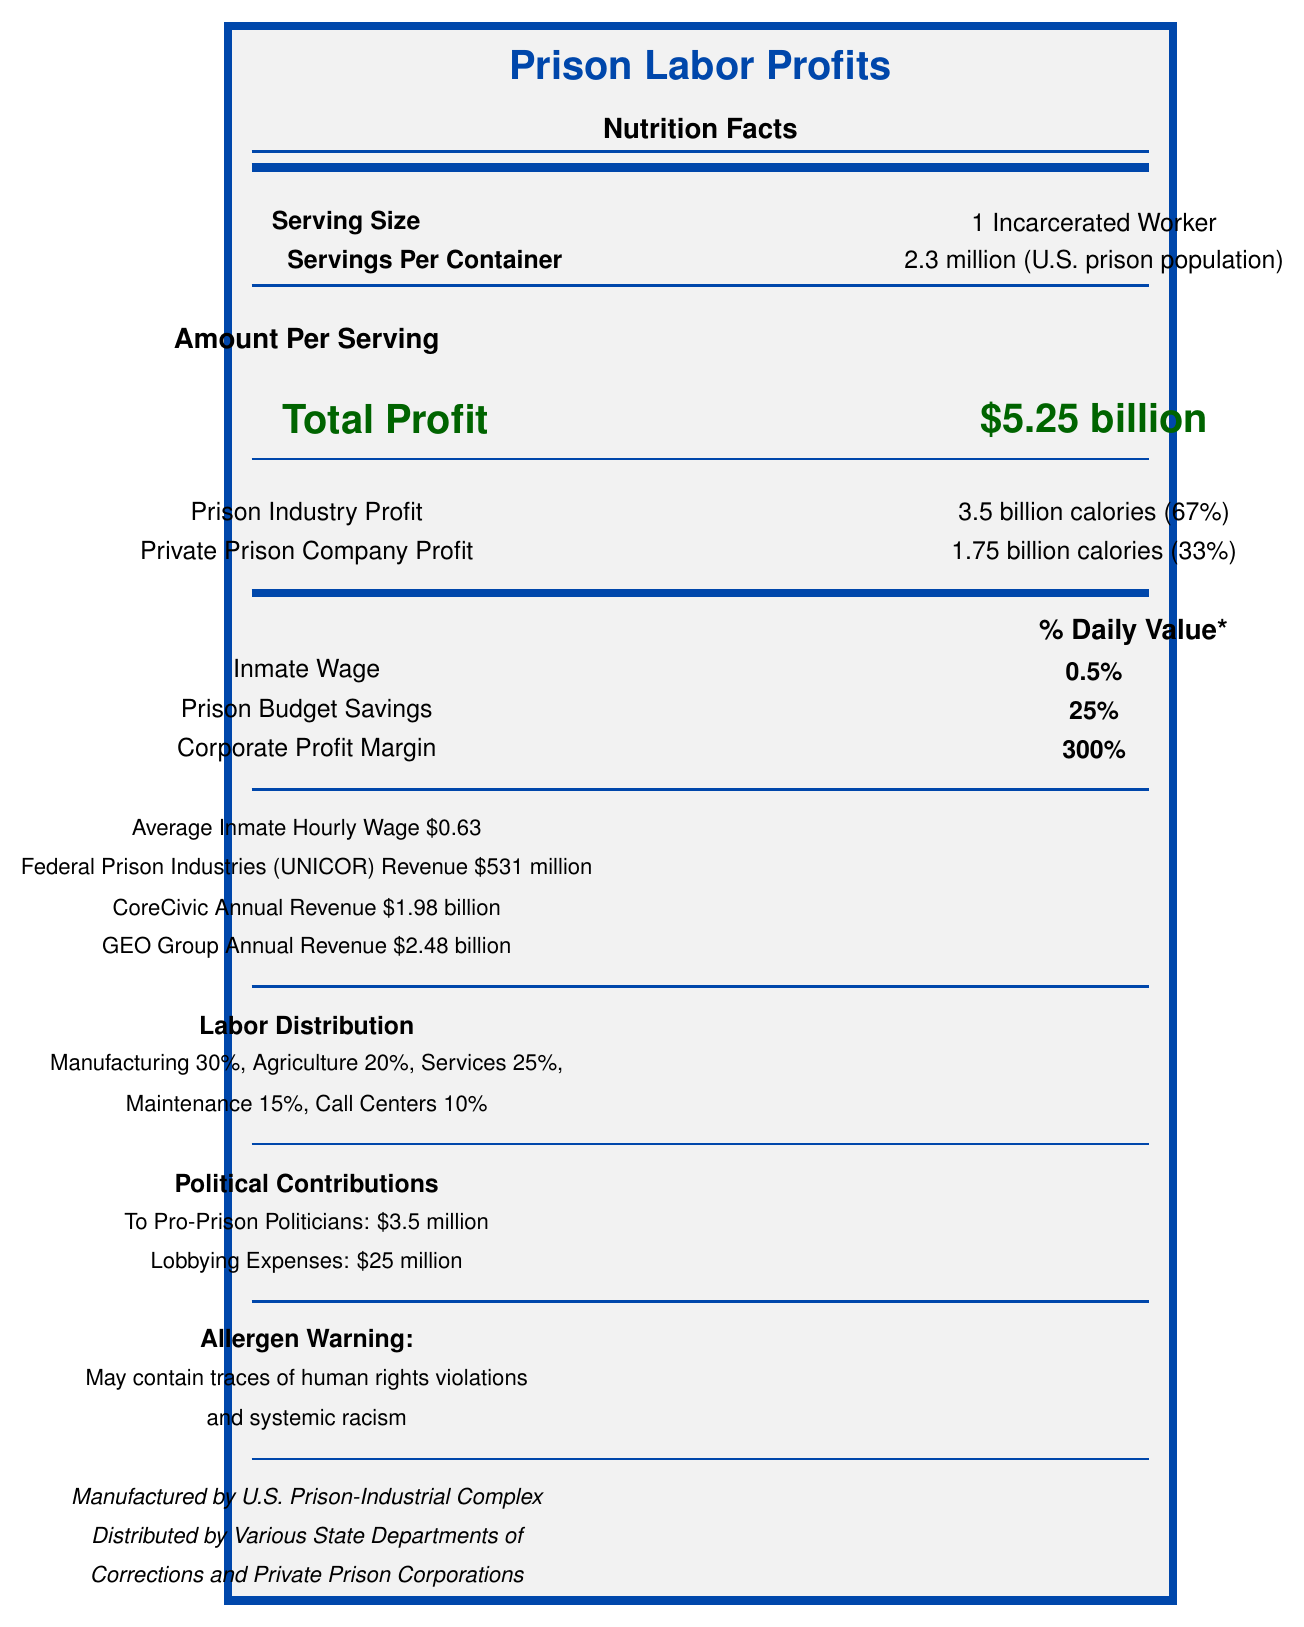what is the total profit from prison labor? The document lists "Total Profit" as $5.25 billion.
Answer: $5.25 billion what percentage of the profit do private prison companies take? The document specifies "Private Prison Company Profit" as 33%.
Answer: 33% what is the average hourly wage for an inmate worker? The document mentions that the "Average Inmate Hourly Wage" is $0.63.
Answer: $0.63 how much do federal prison industries (UNICOR) make annually? The "Federal Prison Industries (UNICOR) Revenue" is listed as $531 million.
Answer: $531 million which industry has the highest distribution of prison labor? The "Labor Distribution" section lists "Manufacturing" at 30%.
Answer: Manufacturing what is the corporate profit margin for prison labor? The document lists "Corporate Profit Margin" as 300%.
Answer: 300% how much are the lobbying expenses related to prison labor? The document lists "Lobbying Expenses" as $25 million.
Answer: $25 million what percentage of prison labor is involved in call centers? The "Labor Distribution" section states that call centers constitute 10% of prison labor.
Answer: 10% which company has the highest annual revenue from prison labor? 
A. UNICOR
B. CoreCivic
C. GEO Group The document lists "GEO Group Annual Revenue" as $2.48 billion, which is higher than the other listed companies.
Answer: C how much are prison budget savings attributed to utilizing prison labor? 
A. 5%
B. 10%
C. 25%
D. 50% The document specifies "Prison Budget Savings" as 25%.
Answer: C does the document indicate a reduction in recidivism due to prison labor programs? The "Recidivism Impact" section shows a "Reduction in Repeat Offenses" as -2%, indicating no reduction.
Answer: No summarize the key components of the prison labor profits document. The detailed summary includes the profits, wage distribution, labor sectors, political contributions, and the impact on recidivism rates.
Answer: The document details the profits generated from prison labor, noting significant total profits of $5.25 billion, with private prison companies obtaining 33% of the total. Inmate wages are low, averaging $0.63 per hour. The labor distribution spans various industries, with manufacturing at 30%. Political contributions and lobbying expenses amount to millions, and there are negative implications on recidivism rates. what are the ingredients listed in the document? The "Ingredients" section lists these as the components.
Answer: Cheap labor, political influence, lack of oversight, exploitative practices how many servings per container are indicated? The document indicates "Servings Per Container" as 2.3 million, corresponding to the U.S. prison population.
Answer: 2.3 million (U.S. prison population) what is the impact of prison labor on recidivism? The "Recidivism Impact" section indicates these figures.
Answer: Increase in prison population by +15% and reduction in repeat offenses by -2% how does the compared wage savings of prison labor differ from industry average? The "Wage Savings" section states a 97% saving compared to the industry average.
Answer: 97% saving compared to industry average what are the political contributions to pro-prison politicians? The "Political Contributions" section lists contributions to pro-prison politicians as $3.5 million.
Answer: $3.5 million are there traces of human rights violations mentioned in the document? The "Allergen Warning" section states that the document may contain traces of human rights violations.
Answer: Yes which major private prison companies are listed in the document? The "Detailed Breakdown" section lists CoreCivic and GEO Group with their respective annual revenues.
Answer: CoreCivic, GEO Group what is the difference in wage savings compared to the minimum wage? The "Wage Savings" section notes a 93% saving compared to the minimum wage.
Answer: 93% what is the total private prison company profit in calories? The "Amount Per Serving" section lists private prison company profit as 1.75 billion calories.
Answer: 1.75 billion calories 